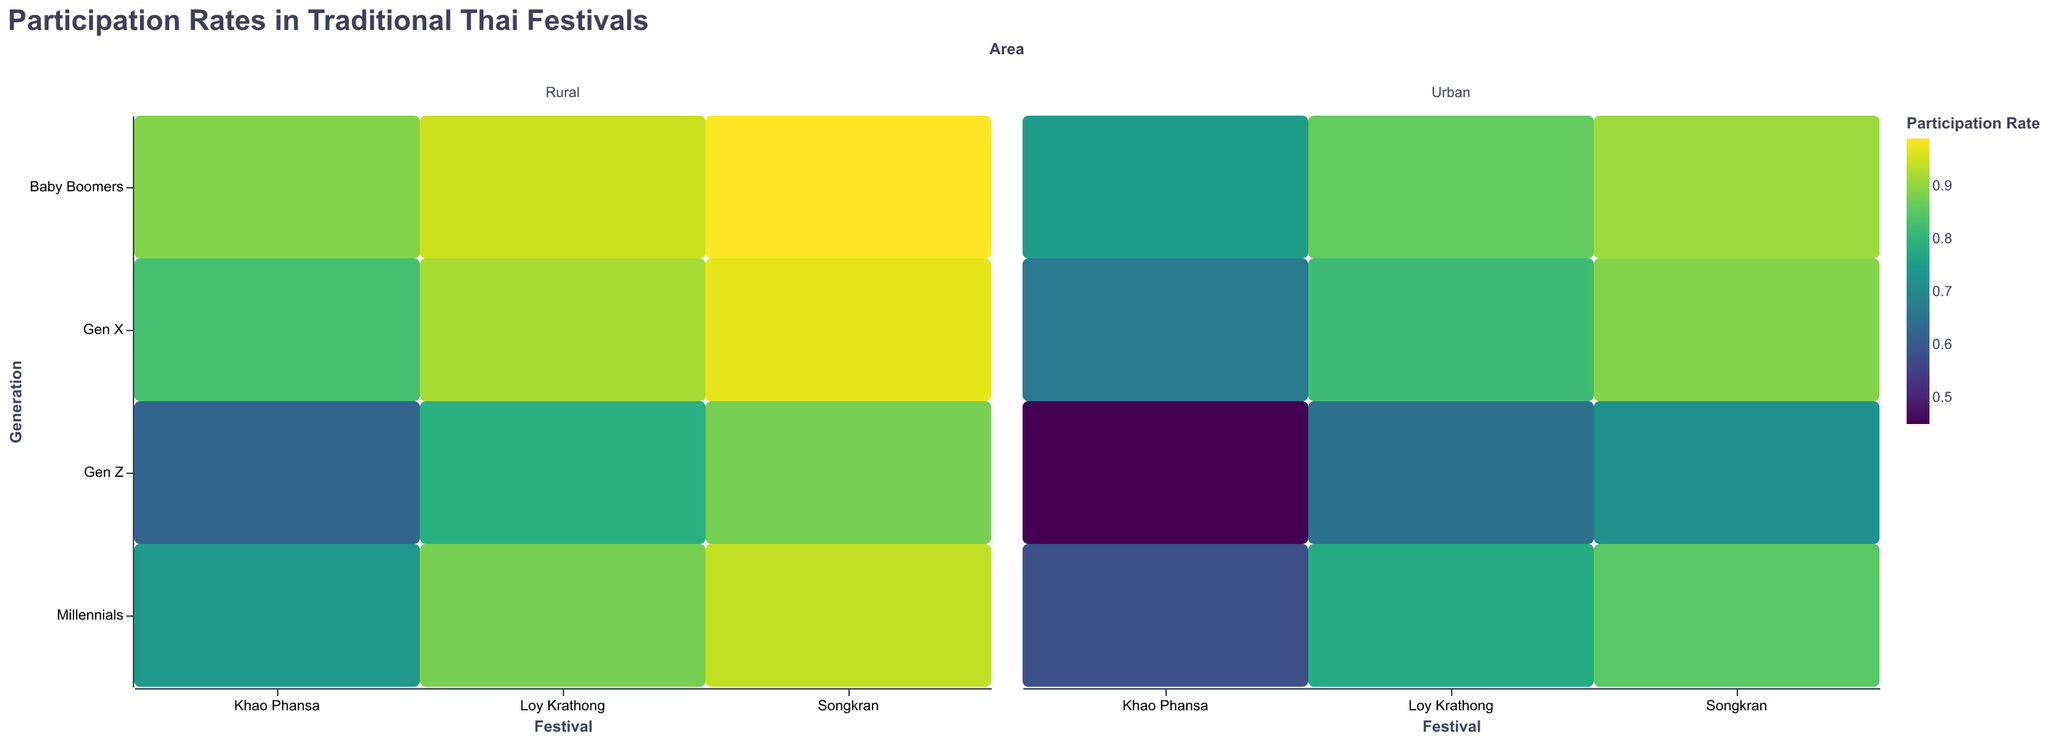What are the participation rates for Gen Z in urban areas across all festivals? Look across the urban column and identify the participation rates for Gen Z in each festival: Songkran (0.72), Loy Krathong (0.65), and Khao Phansa (0.45).
Answer: Songkran: 0.72, Loy Krathong: 0.65, Khao Phansa: 0.45 Which festival has the highest participation rate among Baby Boomers in rural areas? Compare the participation rates for Baby Boomers in the rural column across all festivals: Songkran (0.99), Loy Krathong (0.95), and Khao Phansa (0.89). Songkran has the highest rate.
Answer: Songkran Is the participation rate in Loy Krathong higher for Gen X in rural areas than in urban areas? Compare the participation rates for Gen X in the rural and urban columns for Loy Krathong. Rural is 0.92 and urban is 0.82, thus rural is higher.
Answer: Yes What is the average participation rate for Millennials in urban areas across all festivals? Identify the rates for Millennials in urban areas: Songkran (0.85), Loy Krathong (0.78), and Khao Phansa (0.58). Calculate the average: (0.85 + 0.78 + 0.58) / 3 = 0.7367.
Answer: 0.7367 Between Gen Z and Baby Boomers, who has a higher participation rate in Khao Phansa in rural areas? Compare the participation rates for Khao Phansa in rural areas: Gen Z (0.62) vs. Baby Boomers (0.89). Baby Boomers have a higher rate.
Answer: Baby Boomers How does the participation rate for Songkran among Gen X change between urban and rural areas? Compare the participation rates for Songkran among Gen X in urban (0.89) and rural (0.97) areas.
Answer: Increases by 0.08 Which generation has the largest difference in participation rates between urban and rural areas for Loy Krathong? Calculate the differences in participation rates between urban and rural areas for each generation for Loy Krathong: Gen Z (0.79 - 0.65 = 0.14), Millennials (0.88 - 0.78 = 0.10), Gen X (0.92 - 0.82 = 0.10), and Baby Boomers (0.95 - 0.86 = 0.09). Gen Z has the largest difference.
Answer: Gen Z What is the overall participation trend for Baby Boomers across all festivals in both urban and rural areas? Observe the participation rates for Baby Boomers across all festivals: in urban areas (Songkran: 0.91, Loy Krathong: 0.86, Khao Phansa: 0.75) and in rural areas (Songkran: 0.99, Loy Krathong: 0.95, Khao Phansa: 0.89). Participation is consistently high with rural areas generally higher.
Answer: Consistently high, higher in rural areas 